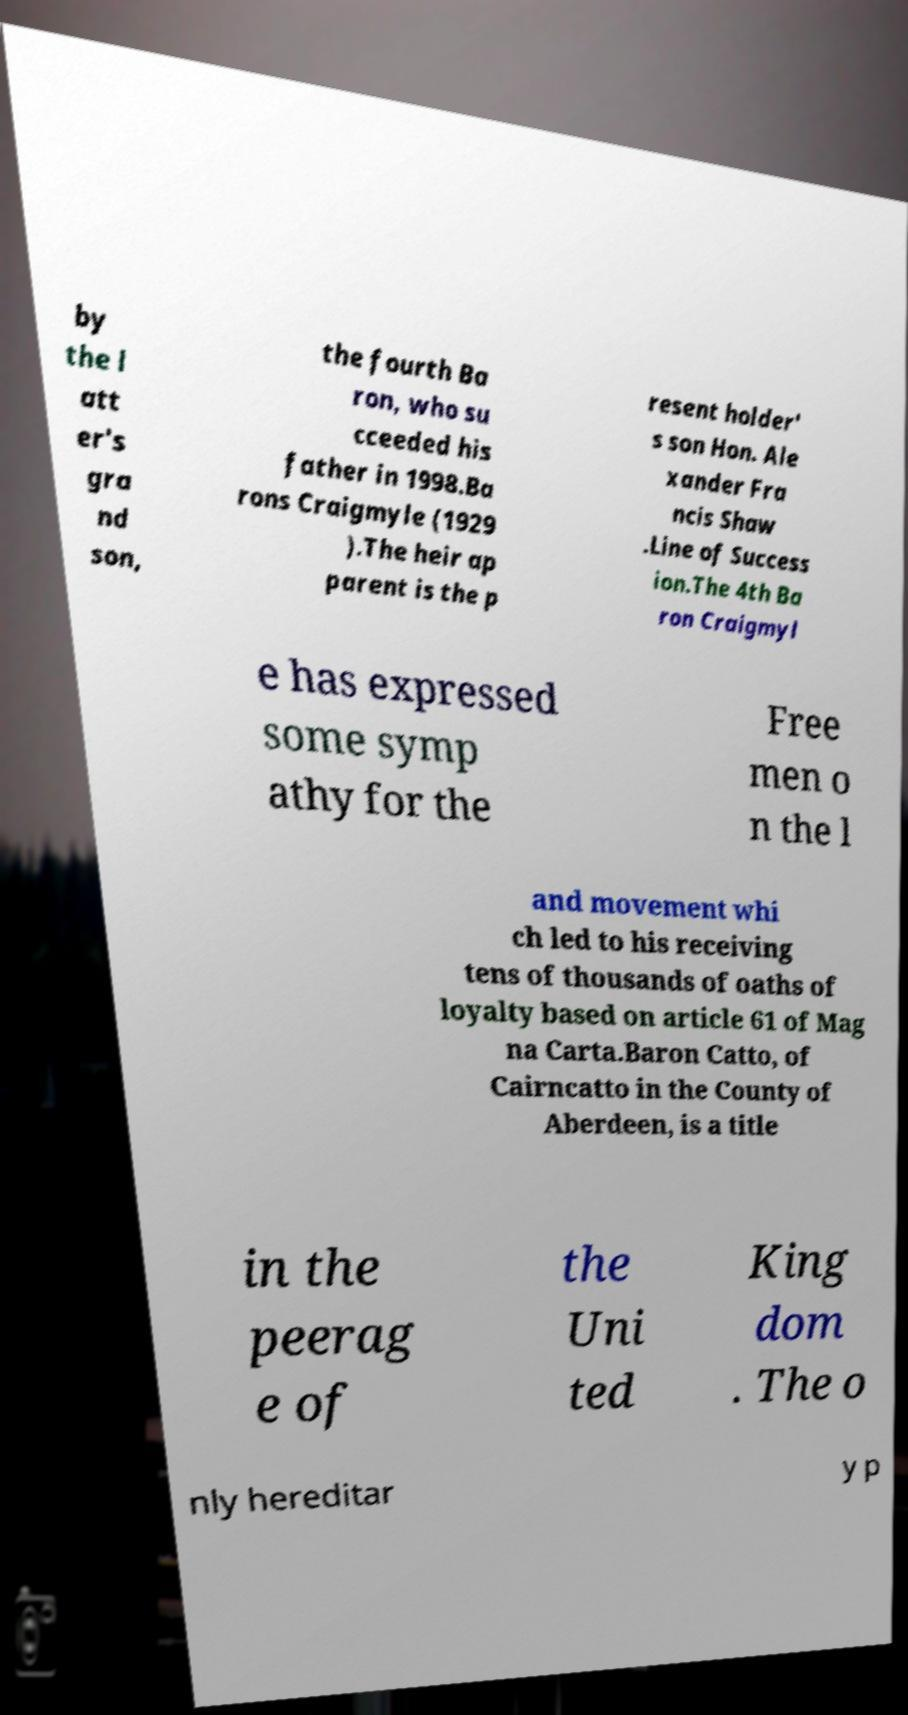Could you extract and type out the text from this image? by the l att er's gra nd son, the fourth Ba ron, who su cceeded his father in 1998.Ba rons Craigmyle (1929 ).The heir ap parent is the p resent holder' s son Hon. Ale xander Fra ncis Shaw .Line of Success ion.The 4th Ba ron Craigmyl e has expressed some symp athy for the Free men o n the l and movement whi ch led to his receiving tens of thousands of oaths of loyalty based on article 61 of Mag na Carta.Baron Catto, of Cairncatto in the County of Aberdeen, is a title in the peerag e of the Uni ted King dom . The o nly hereditar y p 